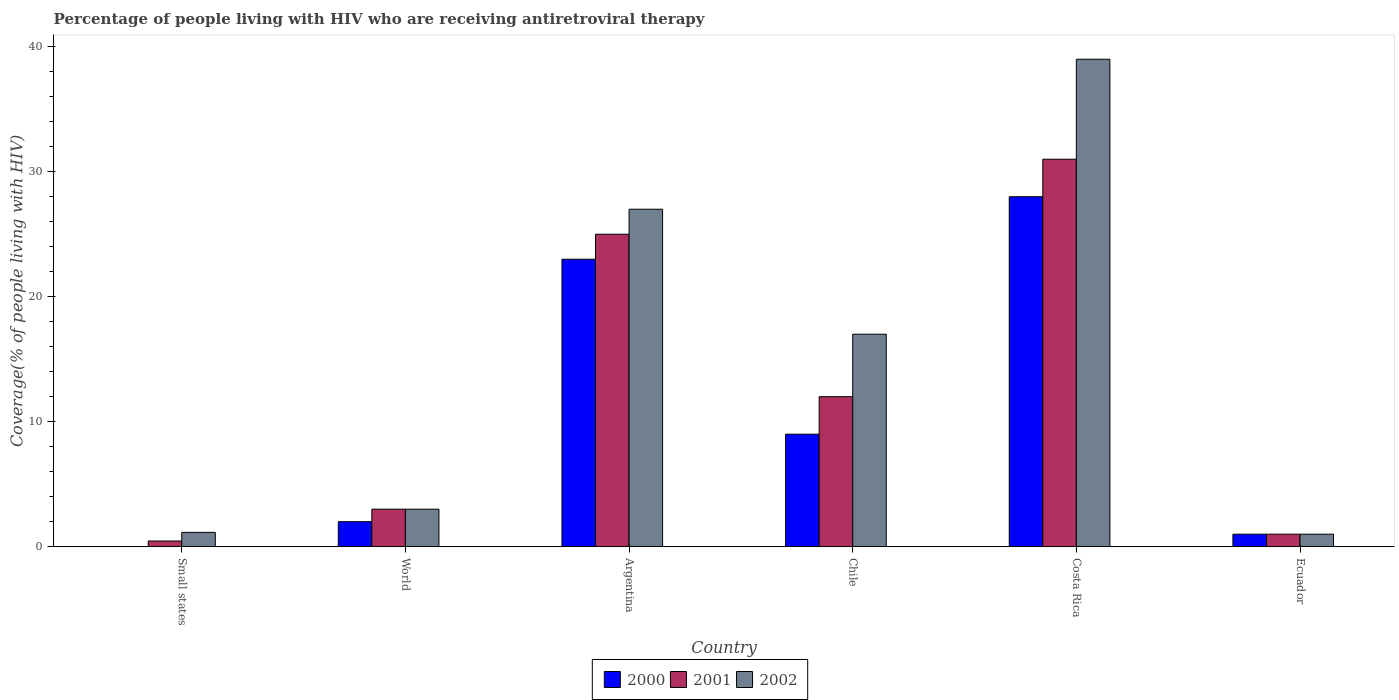How many different coloured bars are there?
Provide a short and direct response. 3. What is the label of the 6th group of bars from the left?
Your response must be concise. Ecuador. Across all countries, what is the minimum percentage of the HIV infected people who are receiving antiretroviral therapy in 2000?
Your answer should be very brief. 0.01. In which country was the percentage of the HIV infected people who are receiving antiretroviral therapy in 2000 maximum?
Offer a terse response. Costa Rica. In which country was the percentage of the HIV infected people who are receiving antiretroviral therapy in 2000 minimum?
Offer a terse response. Small states. What is the total percentage of the HIV infected people who are receiving antiretroviral therapy in 2000 in the graph?
Offer a very short reply. 63.01. What is the difference between the percentage of the HIV infected people who are receiving antiretroviral therapy in 2002 in Ecuador and that in Small states?
Provide a succinct answer. -0.15. What is the difference between the percentage of the HIV infected people who are receiving antiretroviral therapy in 2000 in World and the percentage of the HIV infected people who are receiving antiretroviral therapy in 2002 in Small states?
Ensure brevity in your answer.  0.85. What is the average percentage of the HIV infected people who are receiving antiretroviral therapy in 2002 per country?
Your answer should be very brief. 14.69. What is the difference between the percentage of the HIV infected people who are receiving antiretroviral therapy of/in 2000 and percentage of the HIV infected people who are receiving antiretroviral therapy of/in 2002 in World?
Keep it short and to the point. -1. What is the ratio of the percentage of the HIV infected people who are receiving antiretroviral therapy in 2000 in Argentina to that in Chile?
Offer a terse response. 2.56. Is the difference between the percentage of the HIV infected people who are receiving antiretroviral therapy in 2000 in Ecuador and World greater than the difference between the percentage of the HIV infected people who are receiving antiretroviral therapy in 2002 in Ecuador and World?
Offer a very short reply. Yes. What is the difference between the highest and the second highest percentage of the HIV infected people who are receiving antiretroviral therapy in 2002?
Offer a very short reply. -10. What is the difference between the highest and the lowest percentage of the HIV infected people who are receiving antiretroviral therapy in 2001?
Provide a short and direct response. 30.55. In how many countries, is the percentage of the HIV infected people who are receiving antiretroviral therapy in 2002 greater than the average percentage of the HIV infected people who are receiving antiretroviral therapy in 2002 taken over all countries?
Your answer should be compact. 3. Are all the bars in the graph horizontal?
Provide a short and direct response. No. How many countries are there in the graph?
Provide a succinct answer. 6. What is the difference between two consecutive major ticks on the Y-axis?
Give a very brief answer. 10. Are the values on the major ticks of Y-axis written in scientific E-notation?
Keep it short and to the point. No. Does the graph contain any zero values?
Offer a very short reply. No. Does the graph contain grids?
Your response must be concise. No. How many legend labels are there?
Your answer should be compact. 3. What is the title of the graph?
Give a very brief answer. Percentage of people living with HIV who are receiving antiretroviral therapy. What is the label or title of the X-axis?
Keep it short and to the point. Country. What is the label or title of the Y-axis?
Make the answer very short. Coverage(% of people living with HIV). What is the Coverage(% of people living with HIV) in 2000 in Small states?
Give a very brief answer. 0.01. What is the Coverage(% of people living with HIV) in 2001 in Small states?
Your answer should be compact. 0.45. What is the Coverage(% of people living with HIV) of 2002 in Small states?
Offer a very short reply. 1.15. What is the Coverage(% of people living with HIV) of 2001 in World?
Give a very brief answer. 3. What is the Coverage(% of people living with HIV) of 2000 in Argentina?
Your answer should be compact. 23. What is the Coverage(% of people living with HIV) in 2000 in Ecuador?
Offer a terse response. 1. What is the Coverage(% of people living with HIV) of 2001 in Ecuador?
Your response must be concise. 1. Across all countries, what is the maximum Coverage(% of people living with HIV) of 2000?
Your answer should be compact. 28. Across all countries, what is the maximum Coverage(% of people living with HIV) of 2001?
Keep it short and to the point. 31. Across all countries, what is the maximum Coverage(% of people living with HIV) of 2002?
Your response must be concise. 39. Across all countries, what is the minimum Coverage(% of people living with HIV) in 2000?
Your answer should be very brief. 0.01. Across all countries, what is the minimum Coverage(% of people living with HIV) of 2001?
Your answer should be compact. 0.45. What is the total Coverage(% of people living with HIV) in 2000 in the graph?
Your response must be concise. 63.01. What is the total Coverage(% of people living with HIV) in 2001 in the graph?
Offer a terse response. 72.45. What is the total Coverage(% of people living with HIV) in 2002 in the graph?
Your answer should be compact. 88.15. What is the difference between the Coverage(% of people living with HIV) in 2000 in Small states and that in World?
Make the answer very short. -1.99. What is the difference between the Coverage(% of people living with HIV) of 2001 in Small states and that in World?
Offer a very short reply. -2.54. What is the difference between the Coverage(% of people living with HIV) in 2002 in Small states and that in World?
Keep it short and to the point. -1.85. What is the difference between the Coverage(% of people living with HIV) in 2000 in Small states and that in Argentina?
Keep it short and to the point. -22.99. What is the difference between the Coverage(% of people living with HIV) of 2001 in Small states and that in Argentina?
Give a very brief answer. -24.55. What is the difference between the Coverage(% of people living with HIV) of 2002 in Small states and that in Argentina?
Offer a very short reply. -25.85. What is the difference between the Coverage(% of people living with HIV) in 2000 in Small states and that in Chile?
Your answer should be very brief. -8.99. What is the difference between the Coverage(% of people living with HIV) in 2001 in Small states and that in Chile?
Provide a short and direct response. -11.54. What is the difference between the Coverage(% of people living with HIV) in 2002 in Small states and that in Chile?
Make the answer very short. -15.85. What is the difference between the Coverage(% of people living with HIV) of 2000 in Small states and that in Costa Rica?
Keep it short and to the point. -27.99. What is the difference between the Coverage(% of people living with HIV) of 2001 in Small states and that in Costa Rica?
Give a very brief answer. -30.55. What is the difference between the Coverage(% of people living with HIV) of 2002 in Small states and that in Costa Rica?
Give a very brief answer. -37.85. What is the difference between the Coverage(% of people living with HIV) of 2000 in Small states and that in Ecuador?
Your answer should be compact. -0.99. What is the difference between the Coverage(% of people living with HIV) of 2001 in Small states and that in Ecuador?
Give a very brief answer. -0.55. What is the difference between the Coverage(% of people living with HIV) of 2002 in Small states and that in Ecuador?
Offer a terse response. 0.15. What is the difference between the Coverage(% of people living with HIV) of 2000 in World and that in Argentina?
Your answer should be very brief. -21. What is the difference between the Coverage(% of people living with HIV) in 2001 in World and that in Argentina?
Offer a very short reply. -22. What is the difference between the Coverage(% of people living with HIV) of 2000 in World and that in Chile?
Offer a very short reply. -7. What is the difference between the Coverage(% of people living with HIV) in 2001 in World and that in Chile?
Keep it short and to the point. -9. What is the difference between the Coverage(% of people living with HIV) in 2000 in World and that in Costa Rica?
Your answer should be compact. -26. What is the difference between the Coverage(% of people living with HIV) of 2002 in World and that in Costa Rica?
Keep it short and to the point. -36. What is the difference between the Coverage(% of people living with HIV) in 2002 in World and that in Ecuador?
Your answer should be very brief. 2. What is the difference between the Coverage(% of people living with HIV) of 2000 in Argentina and that in Costa Rica?
Provide a short and direct response. -5. What is the difference between the Coverage(% of people living with HIV) in 2001 in Argentina and that in Costa Rica?
Provide a succinct answer. -6. What is the difference between the Coverage(% of people living with HIV) in 2002 in Argentina and that in Costa Rica?
Provide a short and direct response. -12. What is the difference between the Coverage(% of people living with HIV) in 2000 in Argentina and that in Ecuador?
Your response must be concise. 22. What is the difference between the Coverage(% of people living with HIV) in 2001 in Argentina and that in Ecuador?
Your answer should be very brief. 24. What is the difference between the Coverage(% of people living with HIV) in 2002 in Argentina and that in Ecuador?
Offer a terse response. 26. What is the difference between the Coverage(% of people living with HIV) of 2000 in Chile and that in Costa Rica?
Make the answer very short. -19. What is the difference between the Coverage(% of people living with HIV) of 2002 in Chile and that in Costa Rica?
Keep it short and to the point. -22. What is the difference between the Coverage(% of people living with HIV) of 2000 in Costa Rica and that in Ecuador?
Provide a short and direct response. 27. What is the difference between the Coverage(% of people living with HIV) of 2002 in Costa Rica and that in Ecuador?
Give a very brief answer. 38. What is the difference between the Coverage(% of people living with HIV) in 2000 in Small states and the Coverage(% of people living with HIV) in 2001 in World?
Your answer should be compact. -2.99. What is the difference between the Coverage(% of people living with HIV) of 2000 in Small states and the Coverage(% of people living with HIV) of 2002 in World?
Provide a succinct answer. -2.99. What is the difference between the Coverage(% of people living with HIV) in 2001 in Small states and the Coverage(% of people living with HIV) in 2002 in World?
Your answer should be compact. -2.54. What is the difference between the Coverage(% of people living with HIV) in 2000 in Small states and the Coverage(% of people living with HIV) in 2001 in Argentina?
Your answer should be very brief. -24.99. What is the difference between the Coverage(% of people living with HIV) in 2000 in Small states and the Coverage(% of people living with HIV) in 2002 in Argentina?
Your answer should be compact. -26.99. What is the difference between the Coverage(% of people living with HIV) in 2001 in Small states and the Coverage(% of people living with HIV) in 2002 in Argentina?
Offer a very short reply. -26.55. What is the difference between the Coverage(% of people living with HIV) of 2000 in Small states and the Coverage(% of people living with HIV) of 2001 in Chile?
Make the answer very short. -11.99. What is the difference between the Coverage(% of people living with HIV) of 2000 in Small states and the Coverage(% of people living with HIV) of 2002 in Chile?
Provide a short and direct response. -16.99. What is the difference between the Coverage(% of people living with HIV) of 2001 in Small states and the Coverage(% of people living with HIV) of 2002 in Chile?
Make the answer very short. -16.55. What is the difference between the Coverage(% of people living with HIV) in 2000 in Small states and the Coverage(% of people living with HIV) in 2001 in Costa Rica?
Your answer should be compact. -30.99. What is the difference between the Coverage(% of people living with HIV) in 2000 in Small states and the Coverage(% of people living with HIV) in 2002 in Costa Rica?
Provide a short and direct response. -38.99. What is the difference between the Coverage(% of people living with HIV) of 2001 in Small states and the Coverage(% of people living with HIV) of 2002 in Costa Rica?
Offer a very short reply. -38.55. What is the difference between the Coverage(% of people living with HIV) in 2000 in Small states and the Coverage(% of people living with HIV) in 2001 in Ecuador?
Give a very brief answer. -0.99. What is the difference between the Coverage(% of people living with HIV) of 2000 in Small states and the Coverage(% of people living with HIV) of 2002 in Ecuador?
Keep it short and to the point. -0.99. What is the difference between the Coverage(% of people living with HIV) in 2001 in Small states and the Coverage(% of people living with HIV) in 2002 in Ecuador?
Your answer should be compact. -0.55. What is the difference between the Coverage(% of people living with HIV) of 2000 in World and the Coverage(% of people living with HIV) of 2001 in Argentina?
Keep it short and to the point. -23. What is the difference between the Coverage(% of people living with HIV) of 2000 in World and the Coverage(% of people living with HIV) of 2002 in Argentina?
Your answer should be compact. -25. What is the difference between the Coverage(% of people living with HIV) of 2001 in World and the Coverage(% of people living with HIV) of 2002 in Argentina?
Keep it short and to the point. -24. What is the difference between the Coverage(% of people living with HIV) in 2000 in World and the Coverage(% of people living with HIV) in 2002 in Costa Rica?
Make the answer very short. -37. What is the difference between the Coverage(% of people living with HIV) of 2001 in World and the Coverage(% of people living with HIV) of 2002 in Costa Rica?
Your answer should be very brief. -36. What is the difference between the Coverage(% of people living with HIV) in 2000 in World and the Coverage(% of people living with HIV) in 2001 in Ecuador?
Provide a succinct answer. 1. What is the difference between the Coverage(% of people living with HIV) of 2001 in World and the Coverage(% of people living with HIV) of 2002 in Ecuador?
Your response must be concise. 2. What is the difference between the Coverage(% of people living with HIV) in 2000 in Argentina and the Coverage(% of people living with HIV) in 2001 in Chile?
Your answer should be very brief. 11. What is the difference between the Coverage(% of people living with HIV) of 2000 in Argentina and the Coverage(% of people living with HIV) of 2002 in Chile?
Your answer should be very brief. 6. What is the difference between the Coverage(% of people living with HIV) in 2001 in Argentina and the Coverage(% of people living with HIV) in 2002 in Chile?
Provide a succinct answer. 8. What is the difference between the Coverage(% of people living with HIV) of 2000 in Argentina and the Coverage(% of people living with HIV) of 2001 in Costa Rica?
Your answer should be very brief. -8. What is the difference between the Coverage(% of people living with HIV) in 2000 in Argentina and the Coverage(% of people living with HIV) in 2002 in Costa Rica?
Offer a very short reply. -16. What is the difference between the Coverage(% of people living with HIV) of 2000 in Argentina and the Coverage(% of people living with HIV) of 2002 in Ecuador?
Provide a short and direct response. 22. What is the difference between the Coverage(% of people living with HIV) in 2001 in Argentina and the Coverage(% of people living with HIV) in 2002 in Ecuador?
Give a very brief answer. 24. What is the difference between the Coverage(% of people living with HIV) in 2000 in Chile and the Coverage(% of people living with HIV) in 2001 in Costa Rica?
Keep it short and to the point. -22. What is the difference between the Coverage(% of people living with HIV) in 2000 in Chile and the Coverage(% of people living with HIV) in 2002 in Costa Rica?
Ensure brevity in your answer.  -30. What is the average Coverage(% of people living with HIV) of 2000 per country?
Provide a succinct answer. 10.5. What is the average Coverage(% of people living with HIV) in 2001 per country?
Make the answer very short. 12.08. What is the average Coverage(% of people living with HIV) in 2002 per country?
Make the answer very short. 14.69. What is the difference between the Coverage(% of people living with HIV) in 2000 and Coverage(% of people living with HIV) in 2001 in Small states?
Ensure brevity in your answer.  -0.44. What is the difference between the Coverage(% of people living with HIV) in 2000 and Coverage(% of people living with HIV) in 2002 in Small states?
Your answer should be very brief. -1.13. What is the difference between the Coverage(% of people living with HIV) in 2001 and Coverage(% of people living with HIV) in 2002 in Small states?
Offer a very short reply. -0.69. What is the difference between the Coverage(% of people living with HIV) of 2000 and Coverage(% of people living with HIV) of 2002 in World?
Ensure brevity in your answer.  -1. What is the difference between the Coverage(% of people living with HIV) in 2000 and Coverage(% of people living with HIV) in 2001 in Chile?
Ensure brevity in your answer.  -3. What is the difference between the Coverage(% of people living with HIV) in 2000 and Coverage(% of people living with HIV) in 2002 in Chile?
Your answer should be very brief. -8. What is the difference between the Coverage(% of people living with HIV) in 2000 and Coverage(% of people living with HIV) in 2002 in Ecuador?
Provide a short and direct response. 0. What is the ratio of the Coverage(% of people living with HIV) in 2000 in Small states to that in World?
Ensure brevity in your answer.  0.01. What is the ratio of the Coverage(% of people living with HIV) of 2001 in Small states to that in World?
Provide a succinct answer. 0.15. What is the ratio of the Coverage(% of people living with HIV) in 2002 in Small states to that in World?
Offer a very short reply. 0.38. What is the ratio of the Coverage(% of people living with HIV) of 2000 in Small states to that in Argentina?
Ensure brevity in your answer.  0. What is the ratio of the Coverage(% of people living with HIV) in 2001 in Small states to that in Argentina?
Your answer should be very brief. 0.02. What is the ratio of the Coverage(% of people living with HIV) in 2002 in Small states to that in Argentina?
Offer a very short reply. 0.04. What is the ratio of the Coverage(% of people living with HIV) of 2000 in Small states to that in Chile?
Give a very brief answer. 0. What is the ratio of the Coverage(% of people living with HIV) in 2001 in Small states to that in Chile?
Make the answer very short. 0.04. What is the ratio of the Coverage(% of people living with HIV) of 2002 in Small states to that in Chile?
Offer a very short reply. 0.07. What is the ratio of the Coverage(% of people living with HIV) of 2000 in Small states to that in Costa Rica?
Your answer should be compact. 0. What is the ratio of the Coverage(% of people living with HIV) in 2001 in Small states to that in Costa Rica?
Keep it short and to the point. 0.01. What is the ratio of the Coverage(% of people living with HIV) in 2002 in Small states to that in Costa Rica?
Your response must be concise. 0.03. What is the ratio of the Coverage(% of people living with HIV) in 2000 in Small states to that in Ecuador?
Your answer should be very brief. 0.01. What is the ratio of the Coverage(% of people living with HIV) in 2001 in Small states to that in Ecuador?
Your answer should be compact. 0.46. What is the ratio of the Coverage(% of people living with HIV) of 2002 in Small states to that in Ecuador?
Make the answer very short. 1.15. What is the ratio of the Coverage(% of people living with HIV) of 2000 in World to that in Argentina?
Your answer should be very brief. 0.09. What is the ratio of the Coverage(% of people living with HIV) in 2001 in World to that in Argentina?
Your response must be concise. 0.12. What is the ratio of the Coverage(% of people living with HIV) of 2002 in World to that in Argentina?
Your answer should be very brief. 0.11. What is the ratio of the Coverage(% of people living with HIV) of 2000 in World to that in Chile?
Make the answer very short. 0.22. What is the ratio of the Coverage(% of people living with HIV) in 2001 in World to that in Chile?
Offer a very short reply. 0.25. What is the ratio of the Coverage(% of people living with HIV) in 2002 in World to that in Chile?
Ensure brevity in your answer.  0.18. What is the ratio of the Coverage(% of people living with HIV) of 2000 in World to that in Costa Rica?
Provide a short and direct response. 0.07. What is the ratio of the Coverage(% of people living with HIV) of 2001 in World to that in Costa Rica?
Your response must be concise. 0.1. What is the ratio of the Coverage(% of people living with HIV) of 2002 in World to that in Costa Rica?
Offer a very short reply. 0.08. What is the ratio of the Coverage(% of people living with HIV) in 2001 in World to that in Ecuador?
Provide a succinct answer. 3. What is the ratio of the Coverage(% of people living with HIV) in 2000 in Argentina to that in Chile?
Provide a succinct answer. 2.56. What is the ratio of the Coverage(% of people living with HIV) in 2001 in Argentina to that in Chile?
Provide a succinct answer. 2.08. What is the ratio of the Coverage(% of people living with HIV) of 2002 in Argentina to that in Chile?
Give a very brief answer. 1.59. What is the ratio of the Coverage(% of people living with HIV) of 2000 in Argentina to that in Costa Rica?
Your answer should be very brief. 0.82. What is the ratio of the Coverage(% of people living with HIV) in 2001 in Argentina to that in Costa Rica?
Keep it short and to the point. 0.81. What is the ratio of the Coverage(% of people living with HIV) in 2002 in Argentina to that in Costa Rica?
Your answer should be compact. 0.69. What is the ratio of the Coverage(% of people living with HIV) in 2002 in Argentina to that in Ecuador?
Offer a terse response. 27. What is the ratio of the Coverage(% of people living with HIV) in 2000 in Chile to that in Costa Rica?
Keep it short and to the point. 0.32. What is the ratio of the Coverage(% of people living with HIV) of 2001 in Chile to that in Costa Rica?
Provide a succinct answer. 0.39. What is the ratio of the Coverage(% of people living with HIV) of 2002 in Chile to that in Costa Rica?
Your response must be concise. 0.44. What is the ratio of the Coverage(% of people living with HIV) in 2000 in Chile to that in Ecuador?
Your response must be concise. 9. What is the difference between the highest and the lowest Coverage(% of people living with HIV) of 2000?
Your answer should be compact. 27.99. What is the difference between the highest and the lowest Coverage(% of people living with HIV) of 2001?
Ensure brevity in your answer.  30.55. What is the difference between the highest and the lowest Coverage(% of people living with HIV) of 2002?
Make the answer very short. 38. 